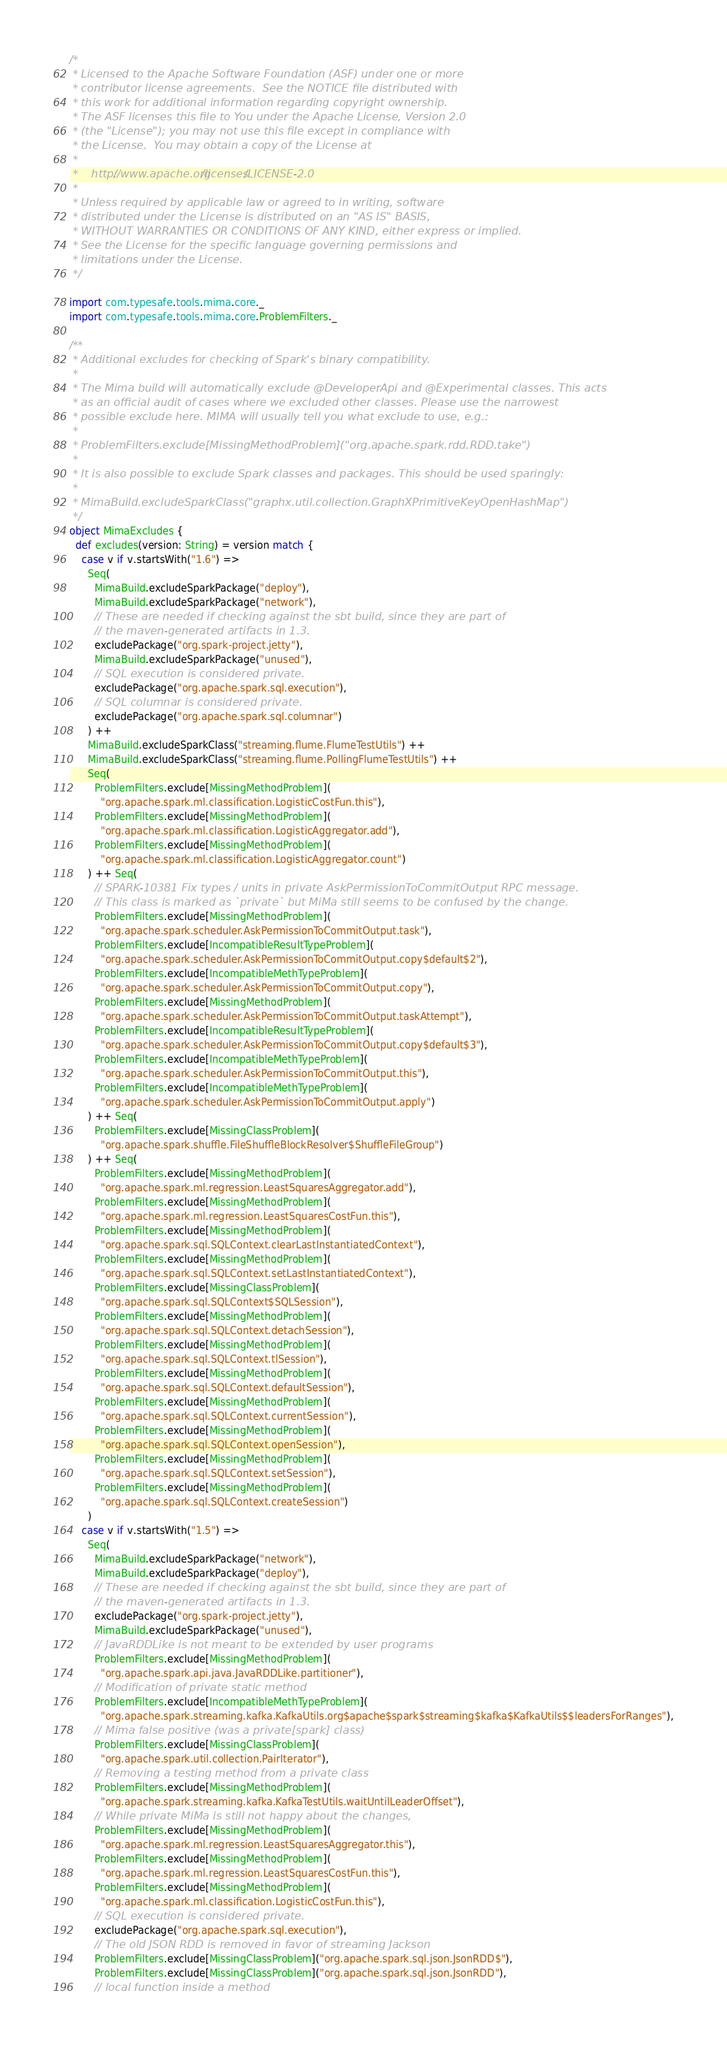<code> <loc_0><loc_0><loc_500><loc_500><_Scala_>/*
 * Licensed to the Apache Software Foundation (ASF) under one or more
 * contributor license agreements.  See the NOTICE file distributed with
 * this work for additional information regarding copyright ownership.
 * The ASF licenses this file to You under the Apache License, Version 2.0
 * (the "License"); you may not use this file except in compliance with
 * the License.  You may obtain a copy of the License at
 *
 *    http://www.apache.org/licenses/LICENSE-2.0
 *
 * Unless required by applicable law or agreed to in writing, software
 * distributed under the License is distributed on an "AS IS" BASIS,
 * WITHOUT WARRANTIES OR CONDITIONS OF ANY KIND, either express or implied.
 * See the License for the specific language governing permissions and
 * limitations under the License.
 */

import com.typesafe.tools.mima.core._
import com.typesafe.tools.mima.core.ProblemFilters._

/**
 * Additional excludes for checking of Spark's binary compatibility.
 *
 * The Mima build will automatically exclude @DeveloperApi and @Experimental classes. This acts
 * as an official audit of cases where we excluded other classes. Please use the narrowest
 * possible exclude here. MIMA will usually tell you what exclude to use, e.g.:
 *
 * ProblemFilters.exclude[MissingMethodProblem]("org.apache.spark.rdd.RDD.take")
 *
 * It is also possible to exclude Spark classes and packages. This should be used sparingly:
 *
 * MimaBuild.excludeSparkClass("graphx.util.collection.GraphXPrimitiveKeyOpenHashMap")
 */
object MimaExcludes {
  def excludes(version: String) = version match {
    case v if v.startsWith("1.6") =>
      Seq(
        MimaBuild.excludeSparkPackage("deploy"),
        MimaBuild.excludeSparkPackage("network"),
        // These are needed if checking against the sbt build, since they are part of
        // the maven-generated artifacts in 1.3.
        excludePackage("org.spark-project.jetty"),
        MimaBuild.excludeSparkPackage("unused"),
        // SQL execution is considered private.
        excludePackage("org.apache.spark.sql.execution"),
        // SQL columnar is considered private.
        excludePackage("org.apache.spark.sql.columnar")
      ) ++
      MimaBuild.excludeSparkClass("streaming.flume.FlumeTestUtils") ++
      MimaBuild.excludeSparkClass("streaming.flume.PollingFlumeTestUtils") ++
      Seq(
        ProblemFilters.exclude[MissingMethodProblem](
          "org.apache.spark.ml.classification.LogisticCostFun.this"),
        ProblemFilters.exclude[MissingMethodProblem](
          "org.apache.spark.ml.classification.LogisticAggregator.add"),
        ProblemFilters.exclude[MissingMethodProblem](
          "org.apache.spark.ml.classification.LogisticAggregator.count")
      ) ++ Seq(
        // SPARK-10381 Fix types / units in private AskPermissionToCommitOutput RPC message.
        // This class is marked as `private` but MiMa still seems to be confused by the change.
        ProblemFilters.exclude[MissingMethodProblem](
          "org.apache.spark.scheduler.AskPermissionToCommitOutput.task"),
        ProblemFilters.exclude[IncompatibleResultTypeProblem](
          "org.apache.spark.scheduler.AskPermissionToCommitOutput.copy$default$2"),
        ProblemFilters.exclude[IncompatibleMethTypeProblem](
          "org.apache.spark.scheduler.AskPermissionToCommitOutput.copy"),
        ProblemFilters.exclude[MissingMethodProblem](
          "org.apache.spark.scheduler.AskPermissionToCommitOutput.taskAttempt"),
        ProblemFilters.exclude[IncompatibleResultTypeProblem](
          "org.apache.spark.scheduler.AskPermissionToCommitOutput.copy$default$3"),
        ProblemFilters.exclude[IncompatibleMethTypeProblem](
          "org.apache.spark.scheduler.AskPermissionToCommitOutput.this"),
        ProblemFilters.exclude[IncompatibleMethTypeProblem](
          "org.apache.spark.scheduler.AskPermissionToCommitOutput.apply")
      ) ++ Seq(
        ProblemFilters.exclude[MissingClassProblem](
          "org.apache.spark.shuffle.FileShuffleBlockResolver$ShuffleFileGroup")
      ) ++ Seq(
        ProblemFilters.exclude[MissingMethodProblem](
          "org.apache.spark.ml.regression.LeastSquaresAggregator.add"),
        ProblemFilters.exclude[MissingMethodProblem](
          "org.apache.spark.ml.regression.LeastSquaresCostFun.this"),
        ProblemFilters.exclude[MissingMethodProblem](
          "org.apache.spark.sql.SQLContext.clearLastInstantiatedContext"),
        ProblemFilters.exclude[MissingMethodProblem](
          "org.apache.spark.sql.SQLContext.setLastInstantiatedContext"),
        ProblemFilters.exclude[MissingClassProblem](
          "org.apache.spark.sql.SQLContext$SQLSession"),
        ProblemFilters.exclude[MissingMethodProblem](
          "org.apache.spark.sql.SQLContext.detachSession"),
        ProblemFilters.exclude[MissingMethodProblem](
          "org.apache.spark.sql.SQLContext.tlSession"),
        ProblemFilters.exclude[MissingMethodProblem](
          "org.apache.spark.sql.SQLContext.defaultSession"),
        ProblemFilters.exclude[MissingMethodProblem](
          "org.apache.spark.sql.SQLContext.currentSession"),
        ProblemFilters.exclude[MissingMethodProblem](
          "org.apache.spark.sql.SQLContext.openSession"),
        ProblemFilters.exclude[MissingMethodProblem](
          "org.apache.spark.sql.SQLContext.setSession"),
        ProblemFilters.exclude[MissingMethodProblem](
          "org.apache.spark.sql.SQLContext.createSession")
      )
    case v if v.startsWith("1.5") =>
      Seq(
        MimaBuild.excludeSparkPackage("network"),
        MimaBuild.excludeSparkPackage("deploy"),
        // These are needed if checking against the sbt build, since they are part of
        // the maven-generated artifacts in 1.3.
        excludePackage("org.spark-project.jetty"),
        MimaBuild.excludeSparkPackage("unused"),
        // JavaRDDLike is not meant to be extended by user programs
        ProblemFilters.exclude[MissingMethodProblem](
          "org.apache.spark.api.java.JavaRDDLike.partitioner"),
        // Modification of private static method
        ProblemFilters.exclude[IncompatibleMethTypeProblem](
          "org.apache.spark.streaming.kafka.KafkaUtils.org$apache$spark$streaming$kafka$KafkaUtils$$leadersForRanges"),
        // Mima false positive (was a private[spark] class)
        ProblemFilters.exclude[MissingClassProblem](
          "org.apache.spark.util.collection.PairIterator"),
        // Removing a testing method from a private class
        ProblemFilters.exclude[MissingMethodProblem](
          "org.apache.spark.streaming.kafka.KafkaTestUtils.waitUntilLeaderOffset"),
        // While private MiMa is still not happy about the changes,
        ProblemFilters.exclude[MissingMethodProblem](
          "org.apache.spark.ml.regression.LeastSquaresAggregator.this"),
        ProblemFilters.exclude[MissingMethodProblem](
          "org.apache.spark.ml.regression.LeastSquaresCostFun.this"),
        ProblemFilters.exclude[MissingMethodProblem](
          "org.apache.spark.ml.classification.LogisticCostFun.this"),
        // SQL execution is considered private.
        excludePackage("org.apache.spark.sql.execution"),
        // The old JSON RDD is removed in favor of streaming Jackson
        ProblemFilters.exclude[MissingClassProblem]("org.apache.spark.sql.json.JsonRDD$"),
        ProblemFilters.exclude[MissingClassProblem]("org.apache.spark.sql.json.JsonRDD"),
        // local function inside a method</code> 